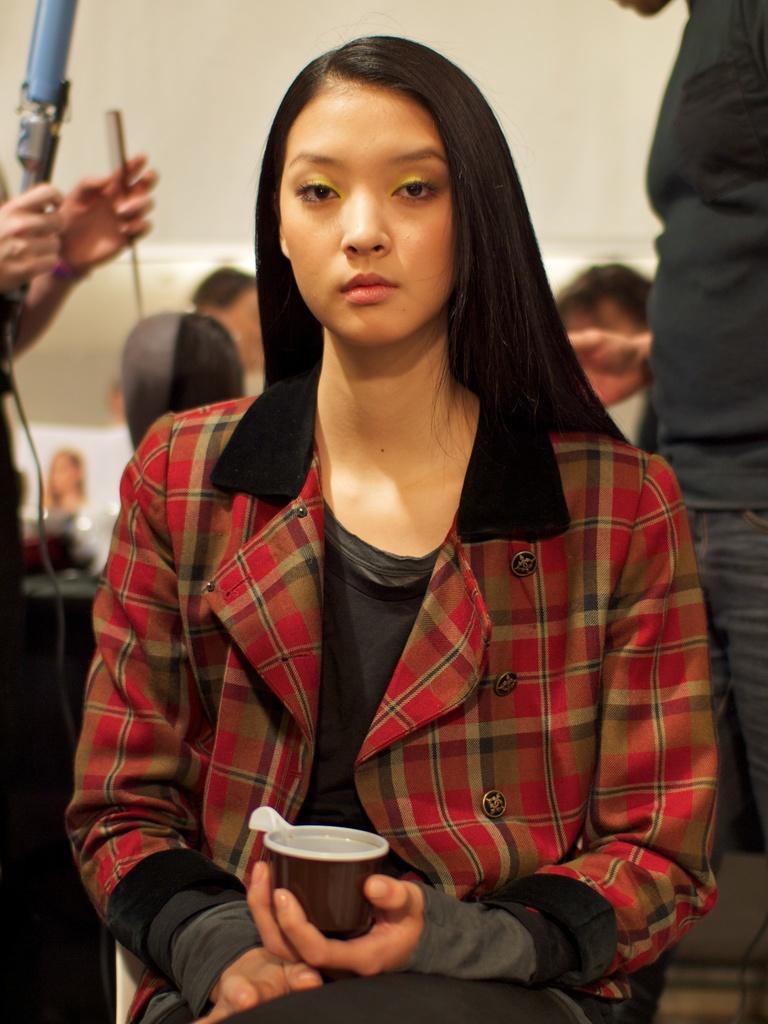Please provide a concise description of this image. In the image we can see there is a woman who is sitting in front and she is holding a cup and at the back there are lot of people. 